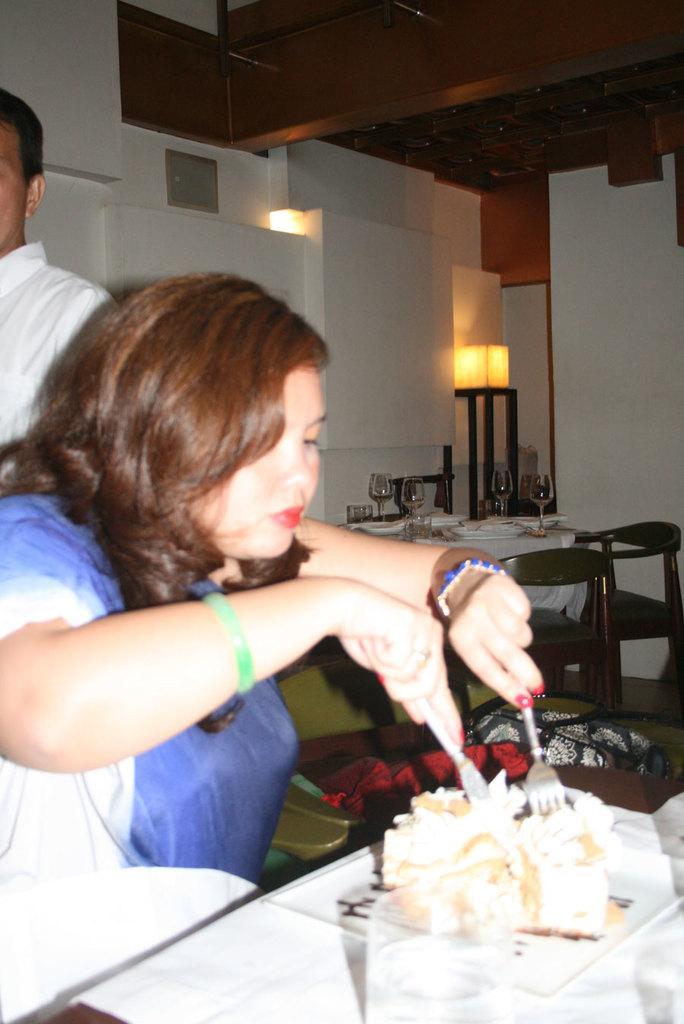Describe this image in one or two sentences. In this picture a woman is sitting on the chair and eating food with the help of a fork. 